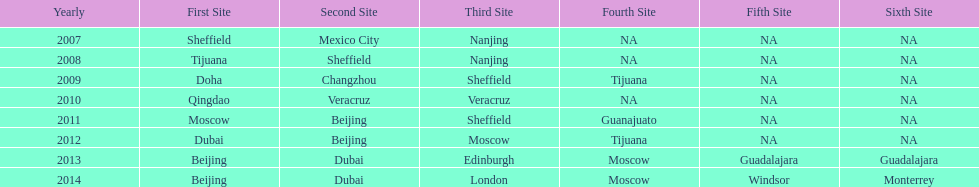Which year is previous to 2011 2010. 